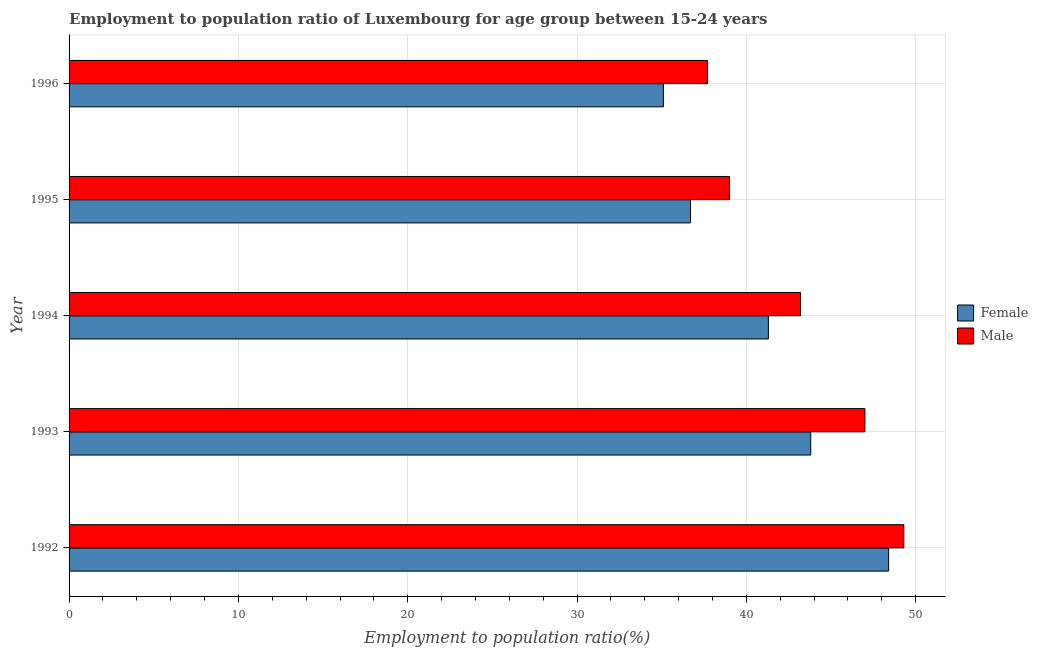How many groups of bars are there?
Give a very brief answer. 5. Are the number of bars per tick equal to the number of legend labels?
Your response must be concise. Yes. Are the number of bars on each tick of the Y-axis equal?
Your response must be concise. Yes. How many bars are there on the 2nd tick from the top?
Offer a very short reply. 2. In how many cases, is the number of bars for a given year not equal to the number of legend labels?
Give a very brief answer. 0. What is the employment to population ratio(female) in 1996?
Offer a terse response. 35.1. Across all years, what is the maximum employment to population ratio(male)?
Offer a terse response. 49.3. Across all years, what is the minimum employment to population ratio(female)?
Ensure brevity in your answer.  35.1. In which year was the employment to population ratio(male) maximum?
Your answer should be very brief. 1992. In which year was the employment to population ratio(female) minimum?
Your answer should be compact. 1996. What is the total employment to population ratio(male) in the graph?
Make the answer very short. 216.2. What is the difference between the employment to population ratio(male) in 1995 and that in 1996?
Your response must be concise. 1.3. What is the difference between the employment to population ratio(male) in 1996 and the employment to population ratio(female) in 1995?
Your answer should be very brief. 1. What is the average employment to population ratio(male) per year?
Make the answer very short. 43.24. In the year 1995, what is the difference between the employment to population ratio(male) and employment to population ratio(female)?
Your answer should be very brief. 2.3. In how many years, is the employment to population ratio(female) greater than 14 %?
Your answer should be compact. 5. What is the ratio of the employment to population ratio(female) in 1992 to that in 1995?
Ensure brevity in your answer.  1.32. Is the employment to population ratio(female) in 1992 less than that in 1994?
Provide a succinct answer. No. Is the difference between the employment to population ratio(female) in 1992 and 1994 greater than the difference between the employment to population ratio(male) in 1992 and 1994?
Give a very brief answer. Yes. What is the difference between the highest and the second highest employment to population ratio(female)?
Offer a very short reply. 4.6. What is the difference between the highest and the lowest employment to population ratio(male)?
Your response must be concise. 11.6. Is the sum of the employment to population ratio(female) in 1994 and 1995 greater than the maximum employment to population ratio(male) across all years?
Offer a very short reply. Yes. What does the 1st bar from the bottom in 1993 represents?
Your response must be concise. Female. Are all the bars in the graph horizontal?
Keep it short and to the point. Yes. How many years are there in the graph?
Offer a terse response. 5. What is the difference between two consecutive major ticks on the X-axis?
Give a very brief answer. 10. Are the values on the major ticks of X-axis written in scientific E-notation?
Make the answer very short. No. Where does the legend appear in the graph?
Offer a terse response. Center right. What is the title of the graph?
Your answer should be very brief. Employment to population ratio of Luxembourg for age group between 15-24 years. What is the label or title of the Y-axis?
Make the answer very short. Year. What is the Employment to population ratio(%) of Female in 1992?
Your answer should be compact. 48.4. What is the Employment to population ratio(%) in Male in 1992?
Provide a succinct answer. 49.3. What is the Employment to population ratio(%) of Female in 1993?
Your answer should be compact. 43.8. What is the Employment to population ratio(%) in Female in 1994?
Provide a succinct answer. 41.3. What is the Employment to population ratio(%) in Male in 1994?
Offer a terse response. 43.2. What is the Employment to population ratio(%) of Female in 1995?
Make the answer very short. 36.7. What is the Employment to population ratio(%) in Female in 1996?
Offer a very short reply. 35.1. What is the Employment to population ratio(%) in Male in 1996?
Provide a succinct answer. 37.7. Across all years, what is the maximum Employment to population ratio(%) of Female?
Provide a short and direct response. 48.4. Across all years, what is the maximum Employment to population ratio(%) in Male?
Your response must be concise. 49.3. Across all years, what is the minimum Employment to population ratio(%) of Female?
Your answer should be very brief. 35.1. Across all years, what is the minimum Employment to population ratio(%) of Male?
Provide a short and direct response. 37.7. What is the total Employment to population ratio(%) of Female in the graph?
Provide a succinct answer. 205.3. What is the total Employment to population ratio(%) of Male in the graph?
Give a very brief answer. 216.2. What is the difference between the Employment to population ratio(%) of Female in 1992 and that in 1993?
Offer a terse response. 4.6. What is the difference between the Employment to population ratio(%) in Male in 1992 and that in 1994?
Provide a short and direct response. 6.1. What is the difference between the Employment to population ratio(%) of Female in 1992 and that in 1995?
Your answer should be very brief. 11.7. What is the difference between the Employment to population ratio(%) of Female in 1993 and that in 1995?
Provide a short and direct response. 7.1. What is the difference between the Employment to population ratio(%) of Female in 1993 and that in 1996?
Offer a terse response. 8.7. What is the difference between the Employment to population ratio(%) of Male in 1994 and that in 1995?
Your answer should be very brief. 4.2. What is the difference between the Employment to population ratio(%) of Female in 1994 and that in 1996?
Provide a short and direct response. 6.2. What is the difference between the Employment to population ratio(%) in Female in 1995 and that in 1996?
Ensure brevity in your answer.  1.6. What is the difference between the Employment to population ratio(%) of Female in 1992 and the Employment to population ratio(%) of Male in 1993?
Provide a short and direct response. 1.4. What is the difference between the Employment to population ratio(%) of Female in 1992 and the Employment to population ratio(%) of Male in 1994?
Your answer should be very brief. 5.2. What is the difference between the Employment to population ratio(%) of Female in 1992 and the Employment to population ratio(%) of Male in 1995?
Provide a short and direct response. 9.4. What is the difference between the Employment to population ratio(%) of Female in 1993 and the Employment to population ratio(%) of Male in 1994?
Provide a short and direct response. 0.6. What is the difference between the Employment to population ratio(%) in Female in 1993 and the Employment to population ratio(%) in Male in 1995?
Provide a succinct answer. 4.8. What is the difference between the Employment to population ratio(%) of Female in 1995 and the Employment to population ratio(%) of Male in 1996?
Offer a terse response. -1. What is the average Employment to population ratio(%) of Female per year?
Your answer should be very brief. 41.06. What is the average Employment to population ratio(%) in Male per year?
Your answer should be very brief. 43.24. In the year 1992, what is the difference between the Employment to population ratio(%) of Female and Employment to population ratio(%) of Male?
Provide a short and direct response. -0.9. In the year 1994, what is the difference between the Employment to population ratio(%) in Female and Employment to population ratio(%) in Male?
Your response must be concise. -1.9. In the year 1995, what is the difference between the Employment to population ratio(%) of Female and Employment to population ratio(%) of Male?
Make the answer very short. -2.3. What is the ratio of the Employment to population ratio(%) of Female in 1992 to that in 1993?
Your answer should be very brief. 1.1. What is the ratio of the Employment to population ratio(%) of Male in 1992 to that in 1993?
Keep it short and to the point. 1.05. What is the ratio of the Employment to population ratio(%) in Female in 1992 to that in 1994?
Provide a succinct answer. 1.17. What is the ratio of the Employment to population ratio(%) of Male in 1992 to that in 1994?
Offer a terse response. 1.14. What is the ratio of the Employment to population ratio(%) of Female in 1992 to that in 1995?
Keep it short and to the point. 1.32. What is the ratio of the Employment to population ratio(%) in Male in 1992 to that in 1995?
Offer a terse response. 1.26. What is the ratio of the Employment to population ratio(%) in Female in 1992 to that in 1996?
Keep it short and to the point. 1.38. What is the ratio of the Employment to population ratio(%) of Male in 1992 to that in 1996?
Provide a short and direct response. 1.31. What is the ratio of the Employment to population ratio(%) of Female in 1993 to that in 1994?
Provide a succinct answer. 1.06. What is the ratio of the Employment to population ratio(%) of Male in 1993 to that in 1994?
Make the answer very short. 1.09. What is the ratio of the Employment to population ratio(%) in Female in 1993 to that in 1995?
Your response must be concise. 1.19. What is the ratio of the Employment to population ratio(%) in Male in 1993 to that in 1995?
Keep it short and to the point. 1.21. What is the ratio of the Employment to population ratio(%) in Female in 1993 to that in 1996?
Your response must be concise. 1.25. What is the ratio of the Employment to population ratio(%) of Male in 1993 to that in 1996?
Your answer should be very brief. 1.25. What is the ratio of the Employment to population ratio(%) in Female in 1994 to that in 1995?
Offer a terse response. 1.13. What is the ratio of the Employment to population ratio(%) in Male in 1994 to that in 1995?
Offer a very short reply. 1.11. What is the ratio of the Employment to population ratio(%) of Female in 1994 to that in 1996?
Provide a succinct answer. 1.18. What is the ratio of the Employment to population ratio(%) in Male in 1994 to that in 1996?
Your answer should be compact. 1.15. What is the ratio of the Employment to population ratio(%) in Female in 1995 to that in 1996?
Provide a short and direct response. 1.05. What is the ratio of the Employment to population ratio(%) of Male in 1995 to that in 1996?
Keep it short and to the point. 1.03. What is the difference between the highest and the second highest Employment to population ratio(%) in Female?
Your answer should be compact. 4.6. What is the difference between the highest and the second highest Employment to population ratio(%) in Male?
Offer a very short reply. 2.3. What is the difference between the highest and the lowest Employment to population ratio(%) in Male?
Provide a short and direct response. 11.6. 